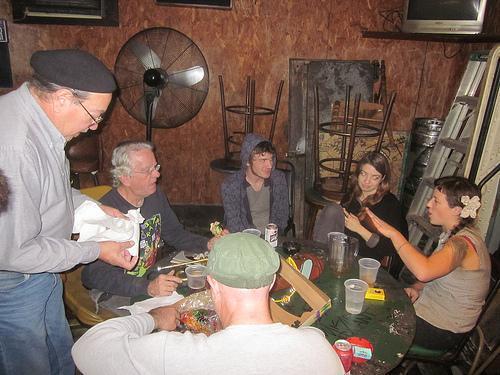How many women are sitting at the table?
Give a very brief answer. 2. How many people are sitting at the table?
Give a very brief answer. 5. How many people have hats?
Give a very brief answer. 2. How many men are in the photograph?
Give a very brief answer. 3. How many of the people in the image have absolutely nothing on their heads but hair?
Give a very brief answer. 2. 